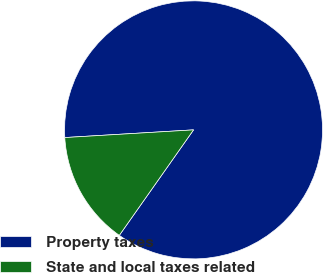Convert chart. <chart><loc_0><loc_0><loc_500><loc_500><pie_chart><fcel>Property taxes<fcel>State and local taxes related<nl><fcel>85.71%<fcel>14.29%<nl></chart> 